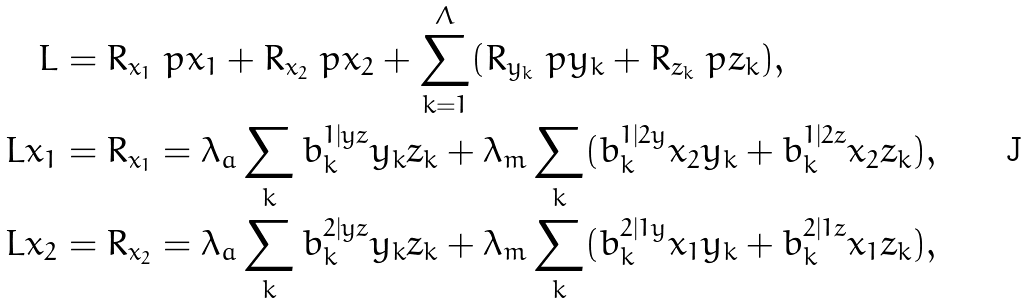Convert formula to latex. <formula><loc_0><loc_0><loc_500><loc_500>L & = R _ { x _ { 1 } } \ p { x _ { 1 } } + R _ { x _ { 2 } } \ p { x _ { 2 } } + \sum _ { k = 1 } ^ { \Lambda } ( R _ { y _ { k } } \ p { y _ { k } } + R _ { z _ { k } } \ p { z _ { k } } ) , \\ L x _ { 1 } & = R _ { x _ { 1 } } = \lambda _ { a } \sum _ { k } b _ { k } ^ { 1 | y z } y _ { k } z _ { k } + \lambda _ { m } \sum _ { k } ( b _ { k } ^ { 1 | 2 y } x _ { 2 } y _ { k } + b _ { k } ^ { 1 | 2 z } x _ { 2 } z _ { k } ) , \\ L x _ { 2 } & = R _ { x _ { 2 } } = \lambda _ { a } \sum _ { k } b _ { k } ^ { 2 | y z } y _ { k } z _ { k } + \lambda _ { m } \sum _ { k } ( b _ { k } ^ { 2 | 1 y } x _ { 1 } y _ { k } + b _ { k } ^ { 2 | 1 z } x _ { 1 } z _ { k } ) ,</formula> 